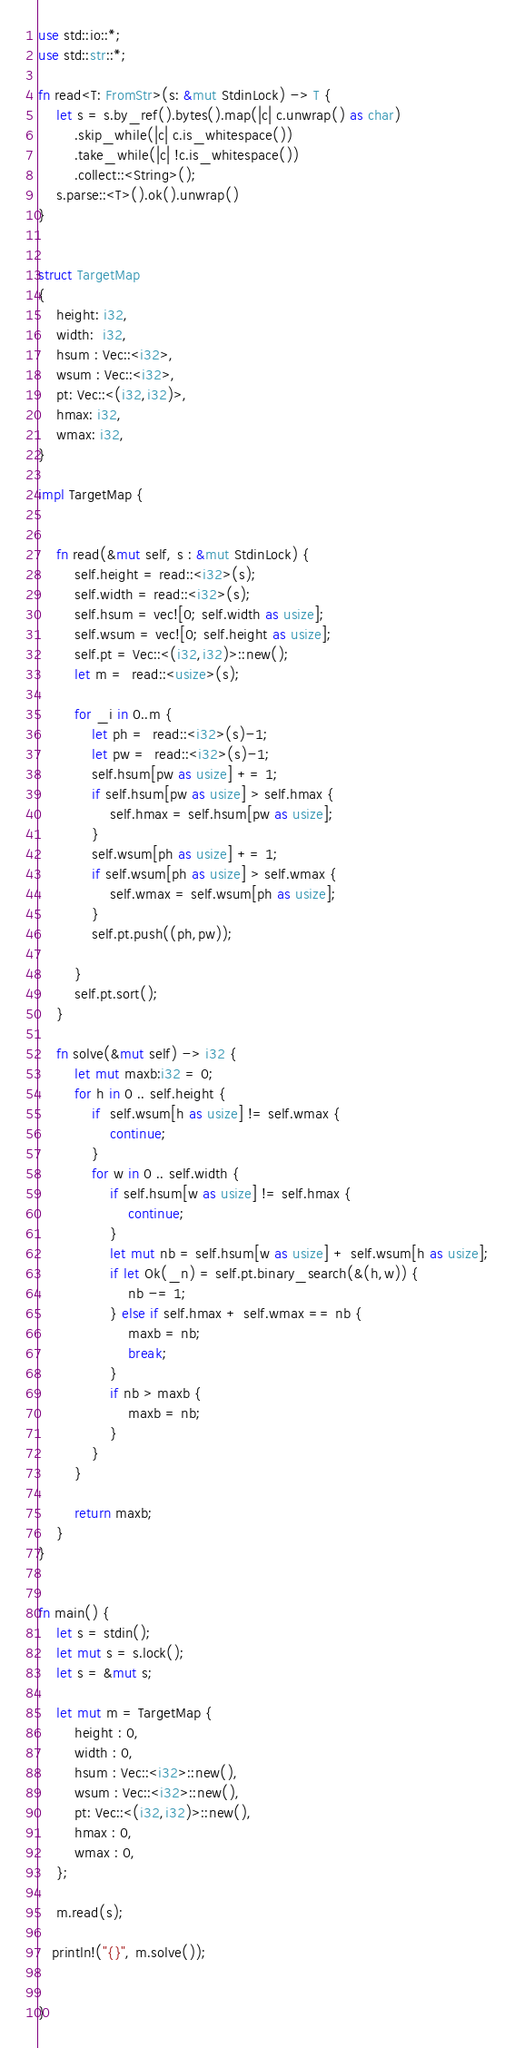<code> <loc_0><loc_0><loc_500><loc_500><_Rust_>use std::io::*;
use std::str::*;

fn read<T: FromStr>(s: &mut StdinLock) -> T {
    let s = s.by_ref().bytes().map(|c| c.unwrap() as char)
        .skip_while(|c| c.is_whitespace())
        .take_while(|c| !c.is_whitespace())
        .collect::<String>();
    s.parse::<T>().ok().unwrap()
}


struct TargetMap 
{
	height: i32,
	width:  i32,
	hsum : Vec::<i32>,
	wsum : Vec::<i32>,
	pt: Vec::<(i32,i32)>,
	hmax: i32,
	wmax: i32,
}

impl TargetMap {


	fn read(&mut self, s : &mut StdinLock) {
		self.height = read::<i32>(s);
		self.width = read::<i32>(s);
		self.hsum = vec![0; self.width as usize];
		self.wsum = vec![0; self.height as usize];
		self.pt = Vec::<(i32,i32)>::new();
		let m =  read::<usize>(s);
	
		for _i in 0..m {
			let ph =  read::<i32>(s)-1;
			let pw =  read::<i32>(s)-1;
			self.hsum[pw as usize] += 1;
			if self.hsum[pw as usize] > self.hmax {
				self.hmax = self.hsum[pw as usize];
			}
			self.wsum[ph as usize] += 1;
			if self.wsum[ph as usize] > self.wmax {
				self.wmax = self.wsum[ph as usize];
			}
			self.pt.push((ph,pw));
		
		}
		self.pt.sort();
	}

	fn solve(&mut self) -> i32 {
		let mut maxb:i32 = 0;
		for h in 0 .. self.height {
			if  self.wsum[h as usize] != self.wmax {
				continue;
			}
			for w in 0 .. self.width {
				if self.hsum[w as usize] != self.hmax {
					continue;
				}
				let mut nb = self.hsum[w as usize] + self.wsum[h as usize];
				if let Ok(_n) = self.pt.binary_search(&(h,w)) {
					nb -= 1;
				} else if self.hmax + self.wmax == nb {
					maxb = nb;
					break;
				}
				if nb > maxb {
					maxb = nb;
				}
			}
		}

		return maxb;
	}
}


fn main() {
    let s = stdin();
    let mut s = s.lock();
    let s = &mut s;

	let mut m = TargetMap {
		height : 0,
		width : 0,
		hsum : Vec::<i32>::new(),
		wsum : Vec::<i32>::new(),
   	    pt: Vec::<(i32,i32)>::new(),
		hmax : 0,
		wmax : 0,
	};

	m.read(s);
	
   println!("{}", m.solve());

	
}

</code> 